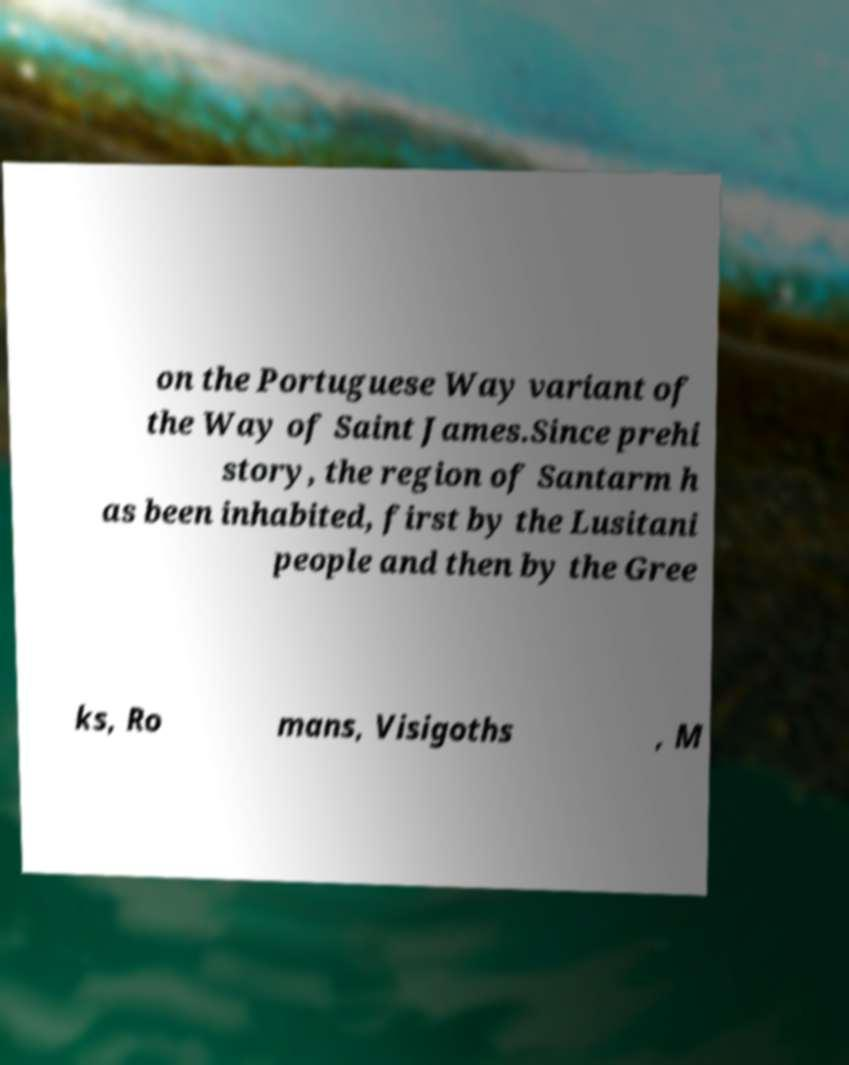Please read and relay the text visible in this image. What does it say? on the Portuguese Way variant of the Way of Saint James.Since prehi story, the region of Santarm h as been inhabited, first by the Lusitani people and then by the Gree ks, Ro mans, Visigoths , M 